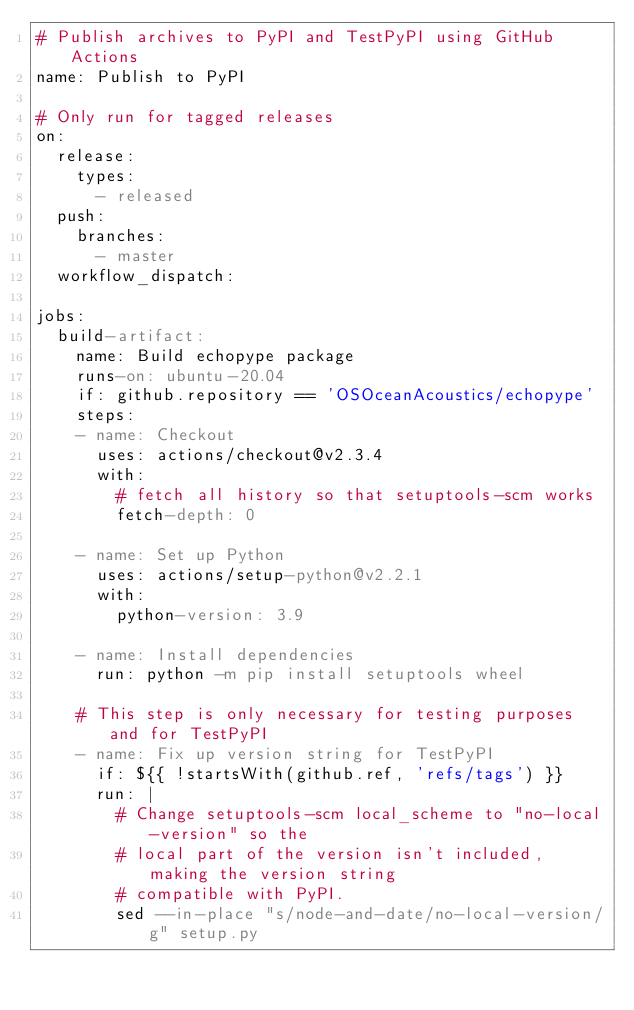<code> <loc_0><loc_0><loc_500><loc_500><_YAML_># Publish archives to PyPI and TestPyPI using GitHub Actions
name: Publish to PyPI

# Only run for tagged releases
on:
  release:
    types:
      - released
  push:
    branches:
      - master
  workflow_dispatch:

jobs:
  build-artifact:
    name: Build echopype package
    runs-on: ubuntu-20.04
    if: github.repository == 'OSOceanAcoustics/echopype'
    steps:
    - name: Checkout
      uses: actions/checkout@v2.3.4
      with:
        # fetch all history so that setuptools-scm works
        fetch-depth: 0

    - name: Set up Python
      uses: actions/setup-python@v2.2.1
      with:
        python-version: 3.9

    - name: Install dependencies
      run: python -m pip install setuptools wheel

    # This step is only necessary for testing purposes and for TestPyPI
    - name: Fix up version string for TestPyPI
      if: ${{ !startsWith(github.ref, 'refs/tags') }}
      run: |
        # Change setuptools-scm local_scheme to "no-local-version" so the
        # local part of the version isn't included, making the version string
        # compatible with PyPI.
        sed --in-place "s/node-and-date/no-local-version/g" setup.py
</code> 